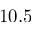<formula> <loc_0><loc_0><loc_500><loc_500>1 0 . 5</formula> 